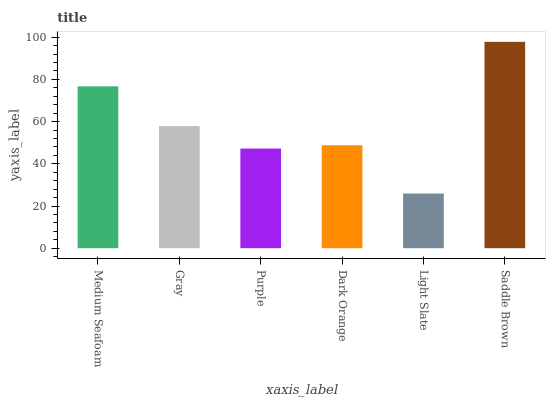Is Light Slate the minimum?
Answer yes or no. Yes. Is Saddle Brown the maximum?
Answer yes or no. Yes. Is Gray the minimum?
Answer yes or no. No. Is Gray the maximum?
Answer yes or no. No. Is Medium Seafoam greater than Gray?
Answer yes or no. Yes. Is Gray less than Medium Seafoam?
Answer yes or no. Yes. Is Gray greater than Medium Seafoam?
Answer yes or no. No. Is Medium Seafoam less than Gray?
Answer yes or no. No. Is Gray the high median?
Answer yes or no. Yes. Is Dark Orange the low median?
Answer yes or no. Yes. Is Saddle Brown the high median?
Answer yes or no. No. Is Gray the low median?
Answer yes or no. No. 